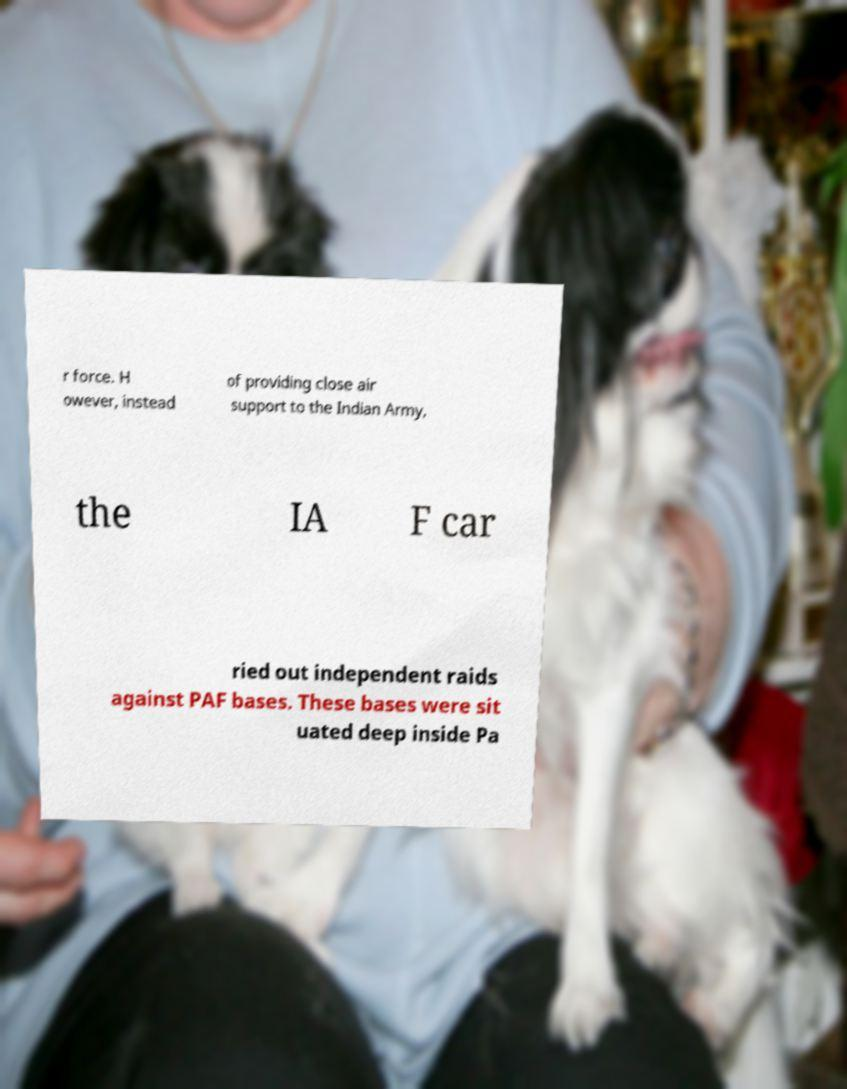Can you accurately transcribe the text from the provided image for me? r force. H owever, instead of providing close air support to the Indian Army, the IA F car ried out independent raids against PAF bases. These bases were sit uated deep inside Pa 